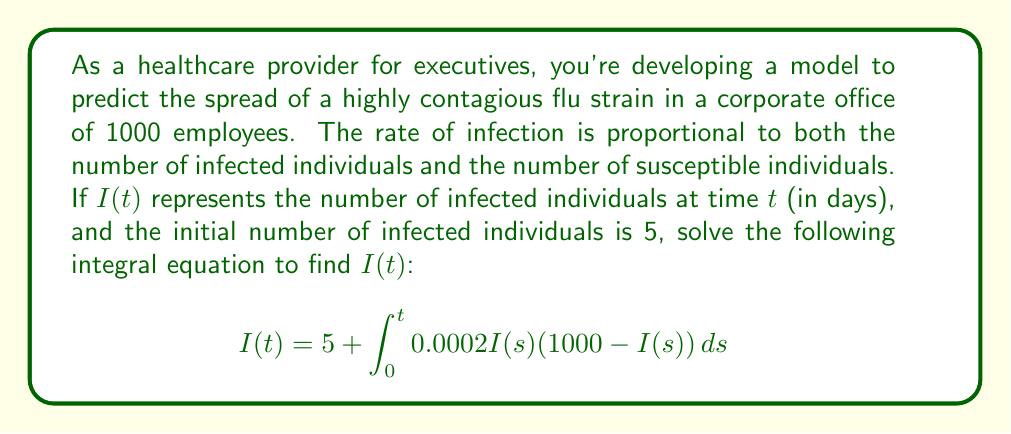Provide a solution to this math problem. To solve this integral equation, we'll follow these steps:

1) First, recognize that this is a nonlinear integral equation of Volterra type.

2) The equation represents a logistic growth model, where:
   - 1000 is the total population
   - 0.0002 is the infection rate constant
   - $I(s)(1000-I(s))$ represents the product of infected and susceptible individuals

3) To solve this, we'll differentiate both sides with respect to $t$:

   $$\frac{dI}{dt} = 0.0002I(t)(1000-I(t))$$

4) This is now a separable differential equation. We can rewrite it as:

   $$\frac{dI}{I(1000-I)} = 0.0002dt$$

5) Integrate both sides:

   $$\int \frac{dI}{I(1000-I)} = \int 0.0002dt$$

6) The left side can be integrated using partial fractions:

   $$\frac{1}{1000}\ln|\frac{I}{1000-I}| = 0.0002t + C$$

7) Solve for $I$:

   $$\frac{I}{1000-I} = Ce^{0.2t}$$
   $$I = \frac{1000Ce^{0.2t}}{1+Ce^{0.2t}}$$

8) Use the initial condition $I(0) = 5$ to find $C$:

   $$5 = \frac{1000C}{1+C}$$
   $$C = \frac{1}{199}$$

9) Substitute this back into our solution:

   $$I(t) = \frac{1000\frac{1}{199}e^{0.2t}}{1+\frac{1}{199}e^{0.2t}}$$

10) Simplify:

    $$I(t) = \frac{1000e^{0.2t}}{199+e^{0.2t}}$$

This is the solution to the integral equation.
Answer: $I(t) = \frac{1000e^{0.2t}}{199+e^{0.2t}}$ 